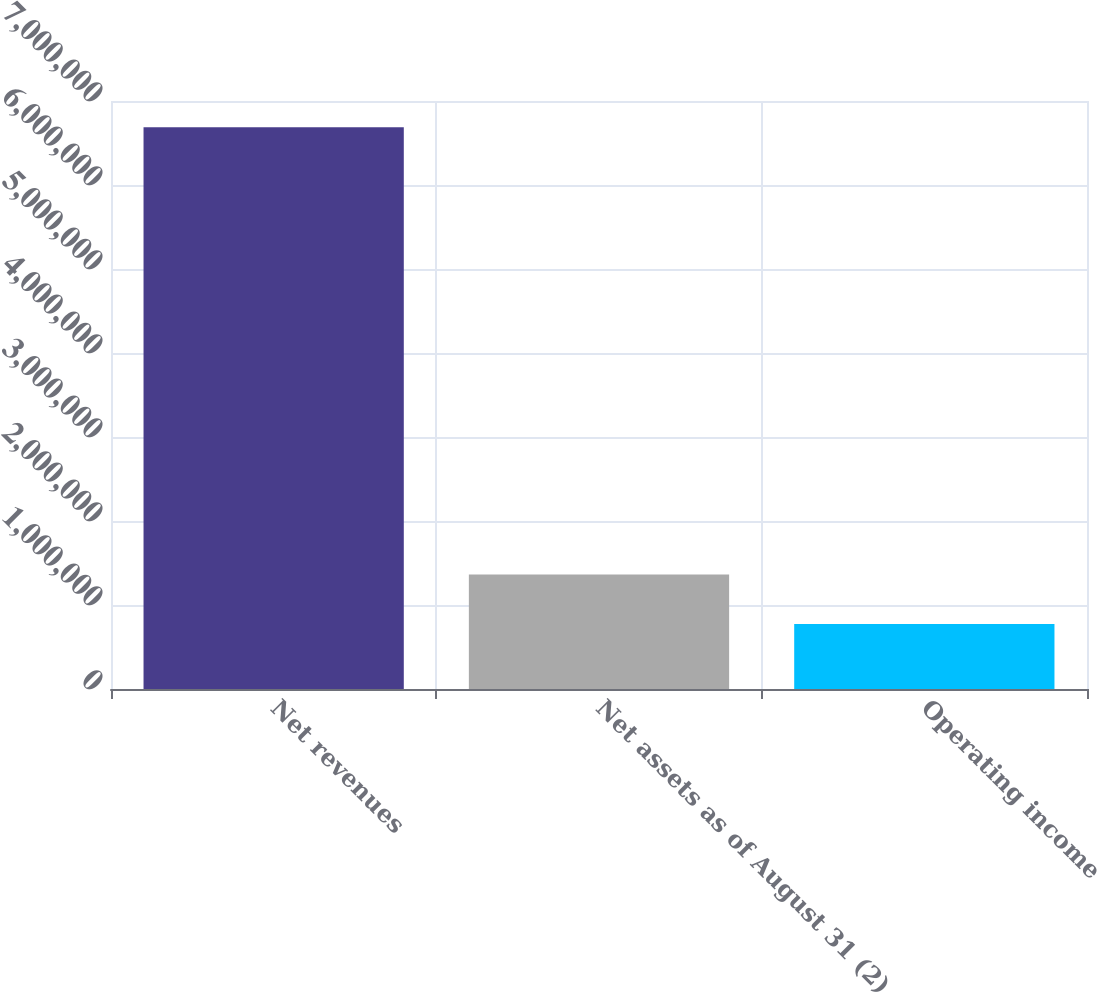<chart> <loc_0><loc_0><loc_500><loc_500><bar_chart><fcel>Net revenues<fcel>Net assets as of August 31 (2)<fcel>Operating income<nl><fcel>6.68847e+06<fcel>1.36435e+06<fcel>772785<nl></chart> 